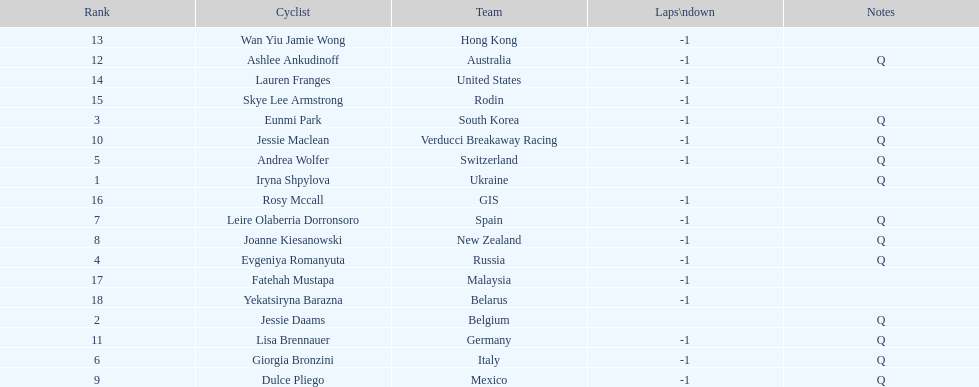What is the number rank of belgium? 2. 